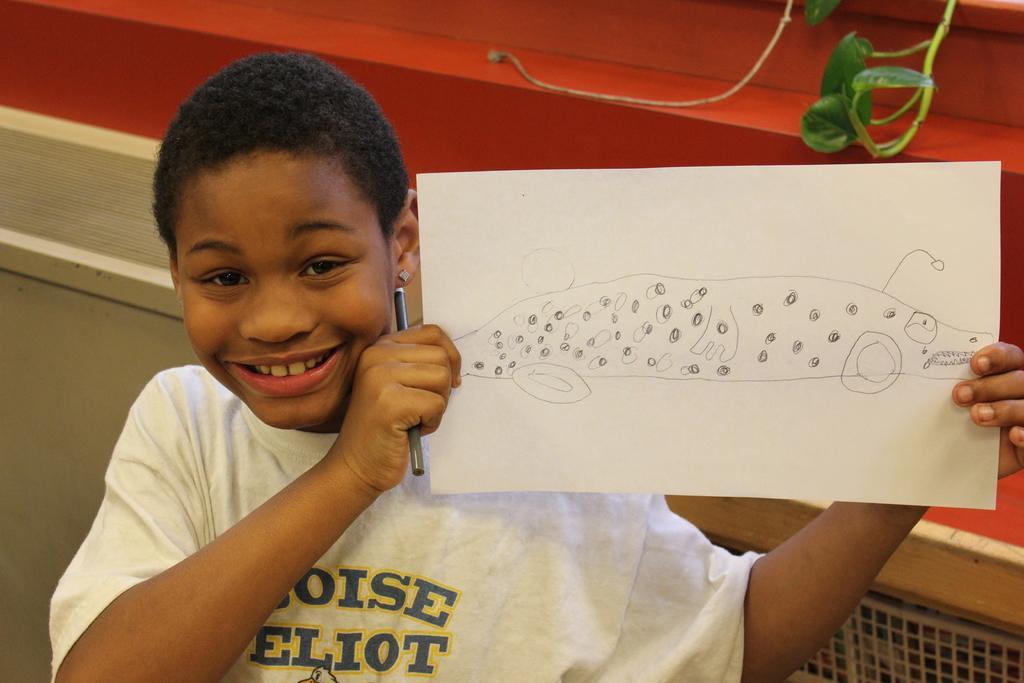Can you describe this image briefly? In the image there is a kid smiling. And the kid is holding a paper and pencil in the hand. On the paper there is a drawing. Behind the kid there is a wall with cupboard and also there are leaves. 